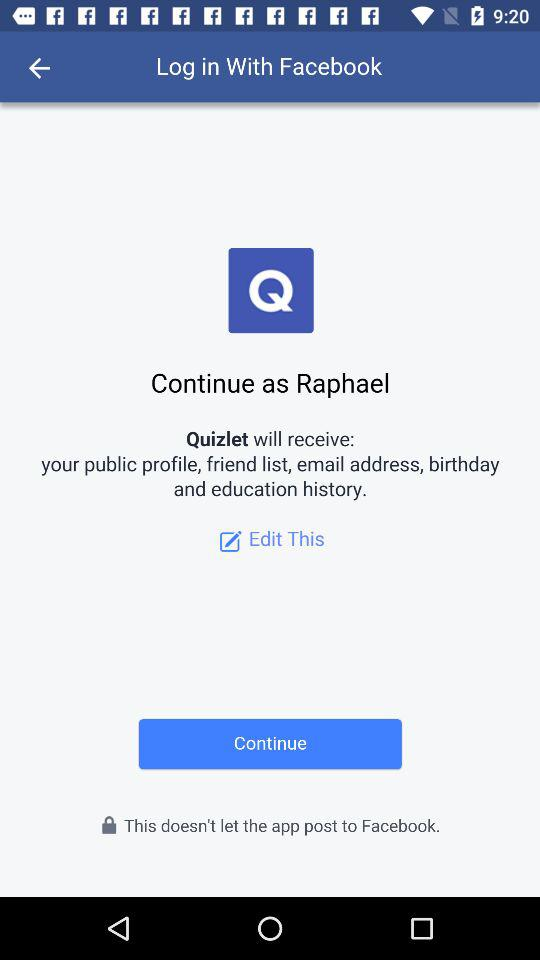What is the user name to continue with the profile? The user name is Raphael. 